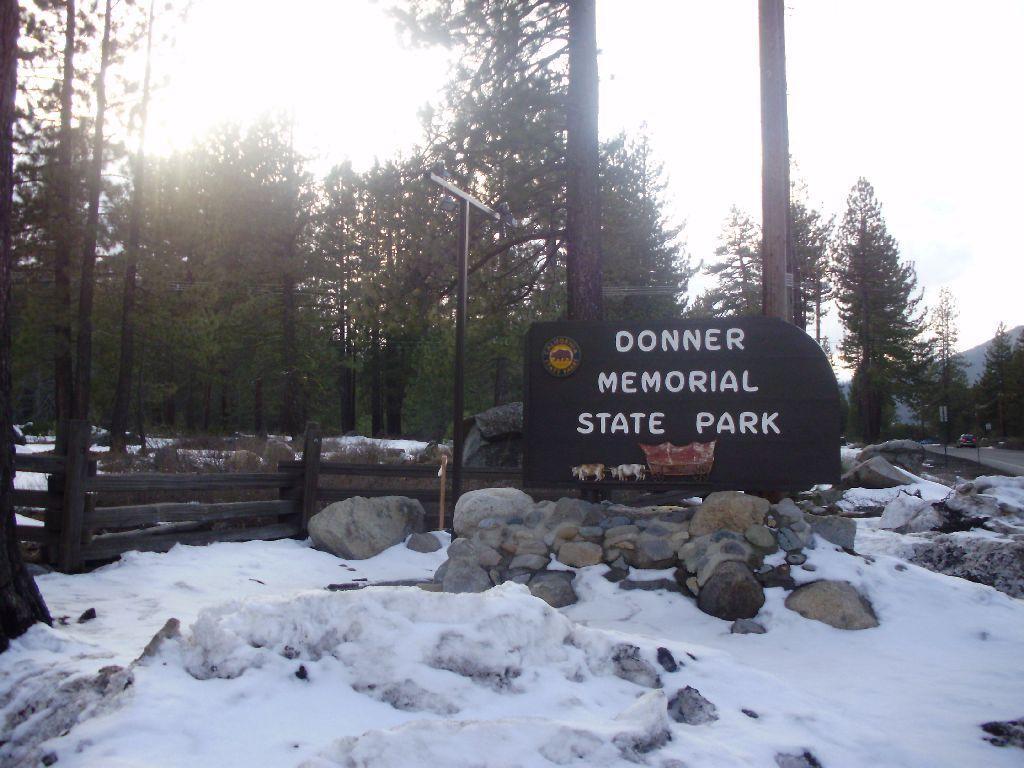Please provide a concise description of this image. In this image I can see the black color board to the side of the rocks. And I can see the donor memorial park is written on it. To the left I can see the railing. And the rocks are on the snow. In the background there are many trees and the white sky. 